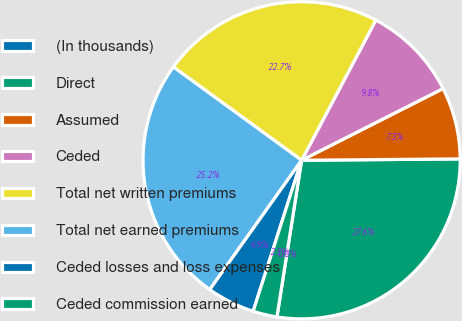<chart> <loc_0><loc_0><loc_500><loc_500><pie_chart><fcel>(In thousands)<fcel>Direct<fcel>Assumed<fcel>Ceded<fcel>Total net written premiums<fcel>Total net earned premiums<fcel>Ceded losses and loss expenses<fcel>Ceded commission earned<nl><fcel>0.01%<fcel>27.62%<fcel>7.33%<fcel>9.78%<fcel>22.74%<fcel>25.18%<fcel>4.89%<fcel>2.45%<nl></chart> 